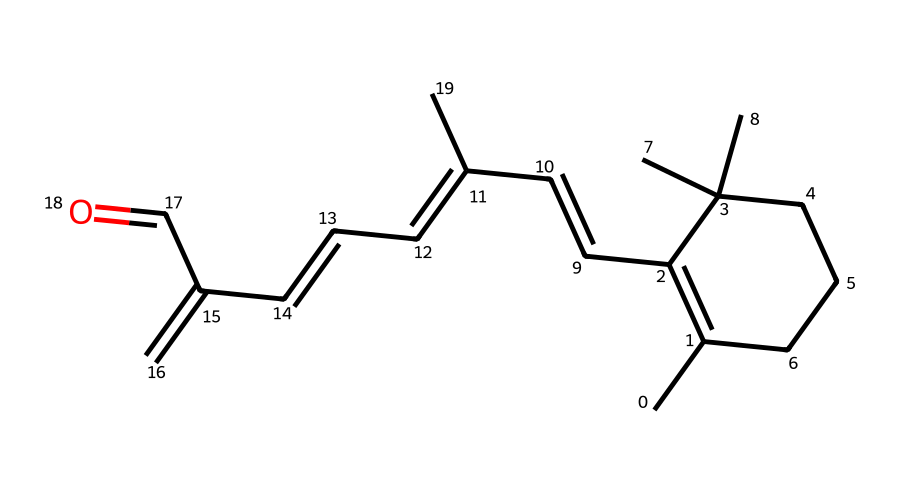What is the molecular formula of retinol? To derive the molecular formula, we can count the number of each type of atom in the given SMILES: there are 20 carbon atoms, 30 hydrogen atoms, and 1 oxygen atom. Therefore, the molecular formula is C20H30O.
Answer: C20H30O How many rings are present in the structure of retinol? By analyzing the structure represented by the SMILES, we find that only one cyclical structure is indicated, hence there is one ring in the molecular structure of retinol.
Answer: 1 What is the primary functional group present in retinol? In the structure, the presence of a carbonyl group (-C=O) indicates that the primary functional group is an aldehyde, with the end carbon of the chain showing this group.
Answer: aldehyde What is the characteristic feature of retinol that contributes to its anti-aging properties? The presence of the conjugated double bond system, as seen repeated in cyclohexene and elsewhere in the structure, provides retinol its biological activity and contributes to its anti-aging properties.
Answer: conjugated double bonds What type of isomerism can retinol exhibit? The presence of multiple double bonds in a structure allows for the possibility of cis/trans (geometric) isomerism due to the different spatial arrangements of atoms around the double bonds in the carbon chain.
Answer: cis/trans isomerism How many double bonds are present in the structural formula of retinol? By carefully inspecting the SMILES representation, we can identify that there are six double bonds within the structure, confirming that retinol has six locations where double bonding occurs.
Answer: 6 